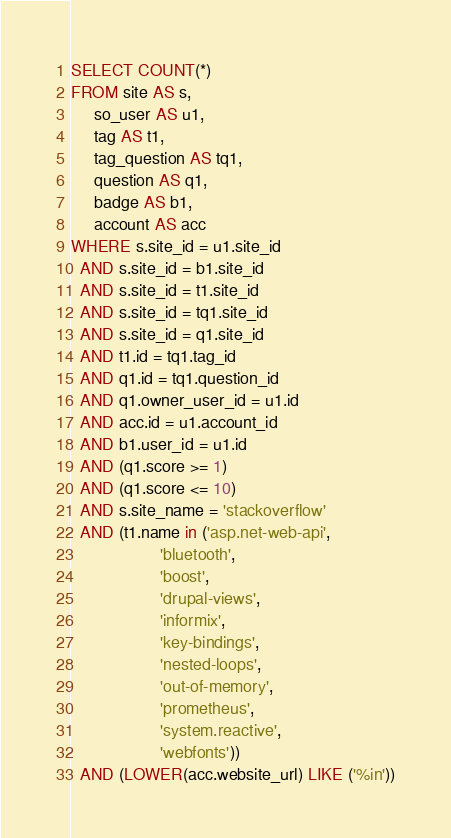<code> <loc_0><loc_0><loc_500><loc_500><_SQL_>SELECT COUNT(*)
FROM site AS s,
     so_user AS u1,
     tag AS t1,
     tag_question AS tq1,
     question AS q1,
     badge AS b1,
     account AS acc
WHERE s.site_id = u1.site_id
  AND s.site_id = b1.site_id
  AND s.site_id = t1.site_id
  AND s.site_id = tq1.site_id
  AND s.site_id = q1.site_id
  AND t1.id = tq1.tag_id
  AND q1.id = tq1.question_id
  AND q1.owner_user_id = u1.id
  AND acc.id = u1.account_id
  AND b1.user_id = u1.id
  AND (q1.score >= 1)
  AND (q1.score <= 10)
  AND s.site_name = 'stackoverflow'
  AND (t1.name in ('asp.net-web-api',
                   'bluetooth',
                   'boost',
                   'drupal-views',
                   'informix',
                   'key-bindings',
                   'nested-loops',
                   'out-of-memory',
                   'prometheus',
                   'system.reactive',
                   'webfonts'))
  AND (LOWER(acc.website_url) LIKE ('%in'))</code> 